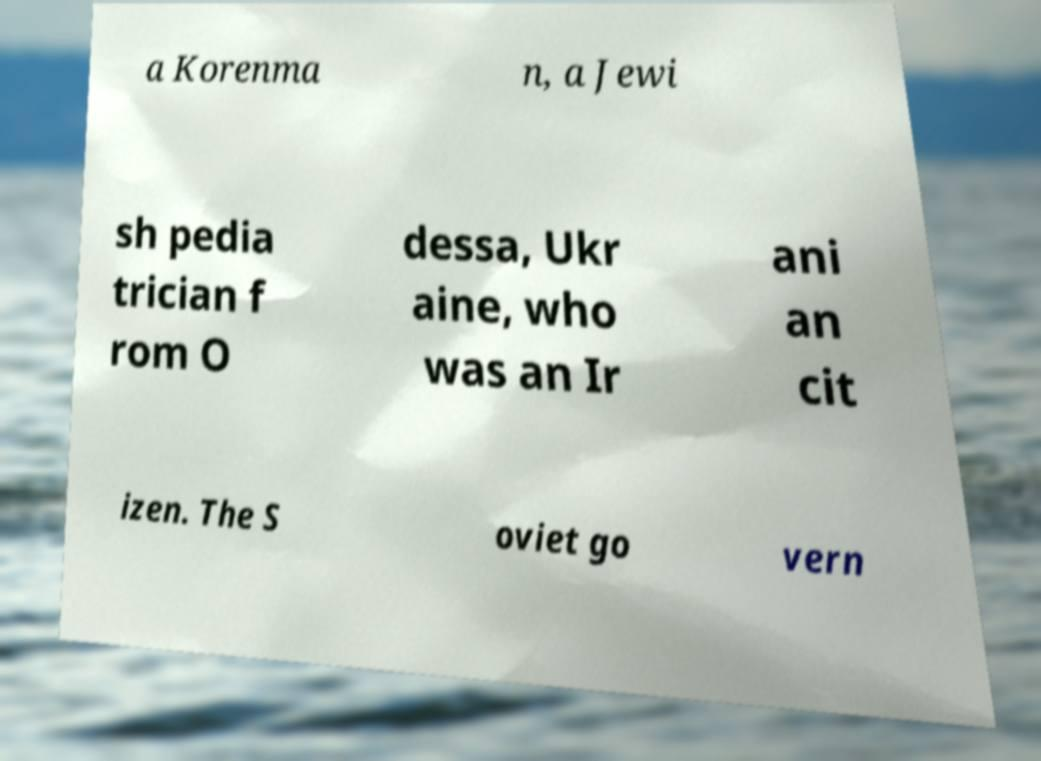Can you read and provide the text displayed in the image?This photo seems to have some interesting text. Can you extract and type it out for me? a Korenma n, a Jewi sh pedia trician f rom O dessa, Ukr aine, who was an Ir ani an cit izen. The S oviet go vern 